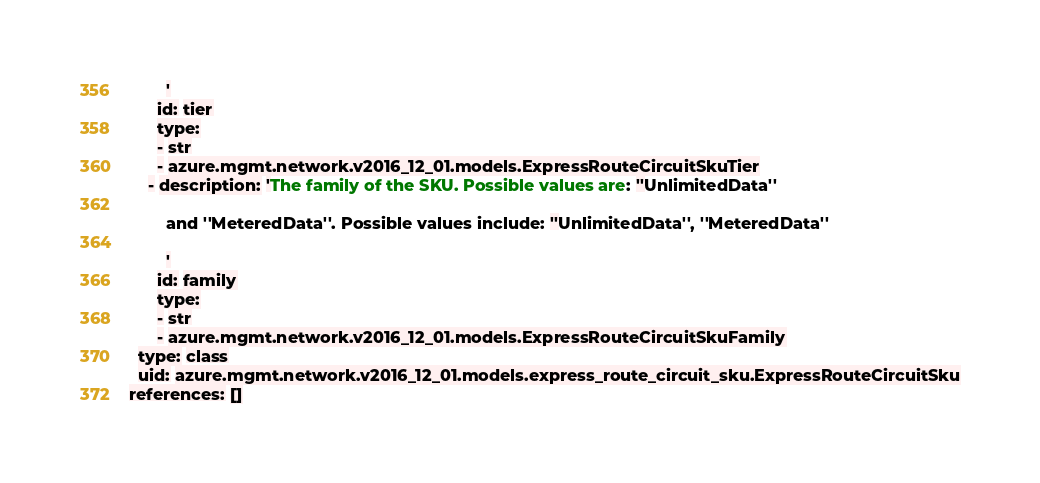<code> <loc_0><loc_0><loc_500><loc_500><_YAML_>        '
      id: tier
      type:
      - str
      - azure.mgmt.network.v2016_12_01.models.ExpressRouteCircuitSkuTier
    - description: 'The family of the SKU. Possible values are: ''UnlimitedData''

        and ''MeteredData''. Possible values include: ''UnlimitedData'', ''MeteredData''

        '
      id: family
      type:
      - str
      - azure.mgmt.network.v2016_12_01.models.ExpressRouteCircuitSkuFamily
  type: class
  uid: azure.mgmt.network.v2016_12_01.models.express_route_circuit_sku.ExpressRouteCircuitSku
references: []
</code> 